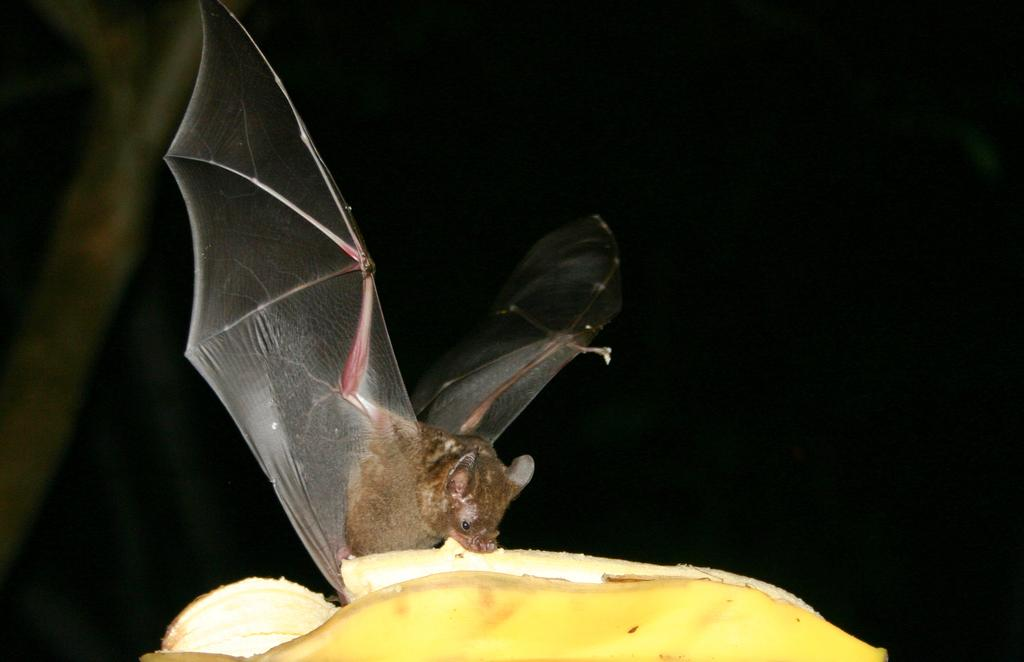What animal is in the image? There is a bat in the image. What is the bat sitting on? The bat is sitting on a banana. How does the bat deliver the parcel in the image? There is no parcel present in the image, so the bat cannot deliver a parcel. 